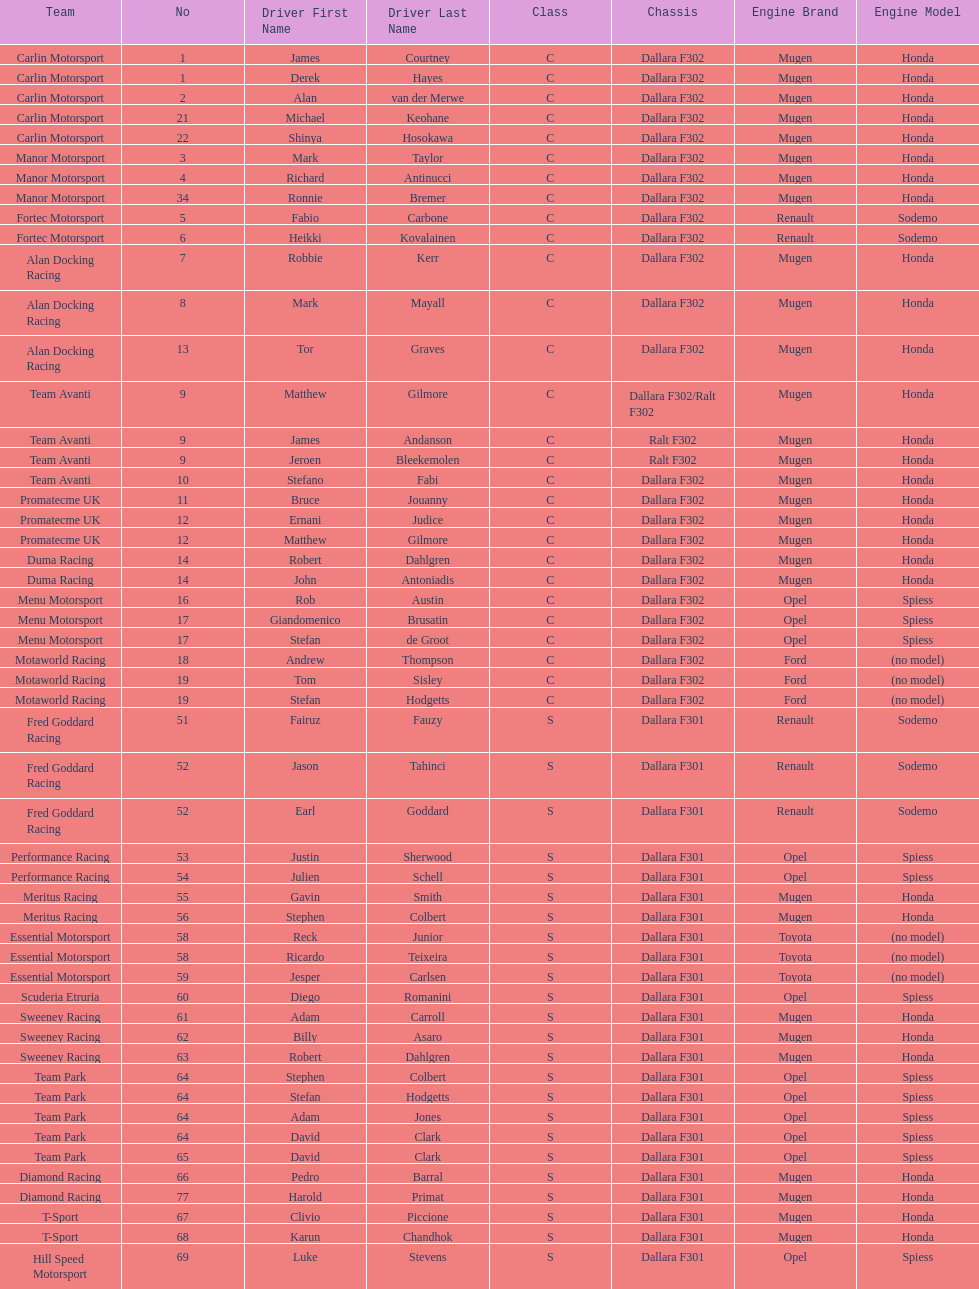How many class s (scholarship) teams are on the chart? 19. 